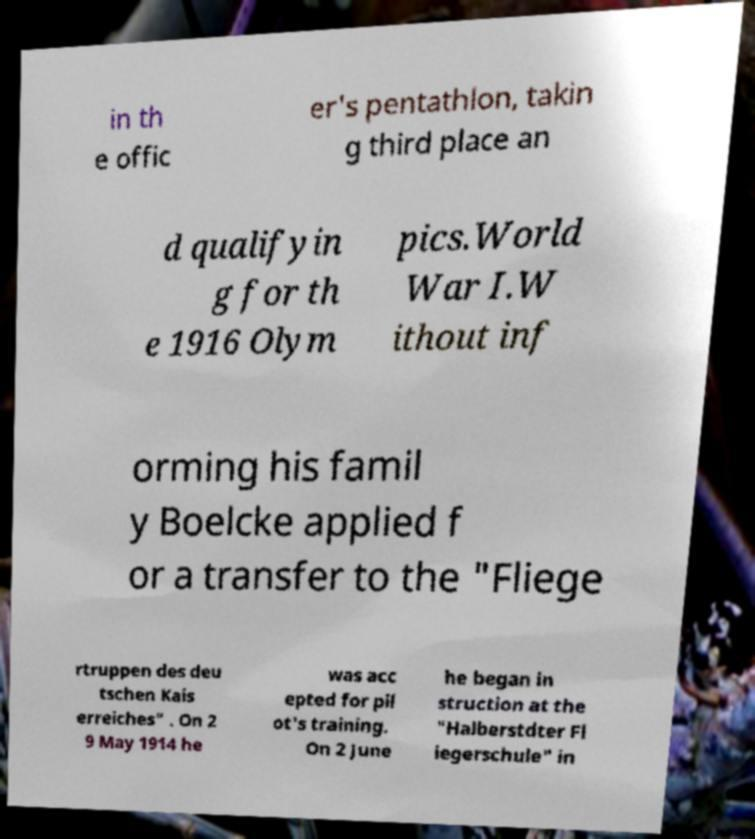There's text embedded in this image that I need extracted. Can you transcribe it verbatim? in th e offic er's pentathlon, takin g third place an d qualifyin g for th e 1916 Olym pics.World War I.W ithout inf orming his famil y Boelcke applied f or a transfer to the "Fliege rtruppen des deu tschen Kais erreiches" . On 2 9 May 1914 he was acc epted for pil ot's training. On 2 June he began in struction at the "Halberstdter Fl iegerschule" in 